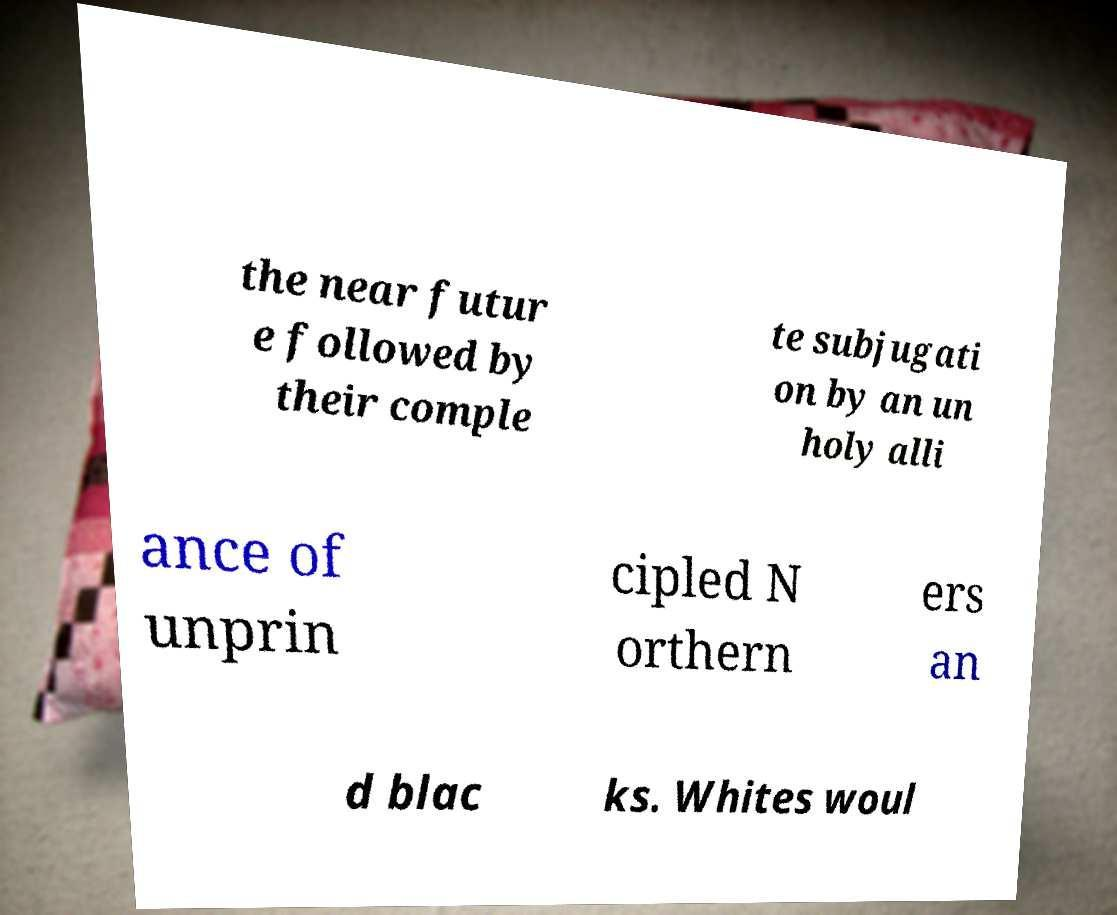There's text embedded in this image that I need extracted. Can you transcribe it verbatim? the near futur e followed by their comple te subjugati on by an un holy alli ance of unprin cipled N orthern ers an d blac ks. Whites woul 